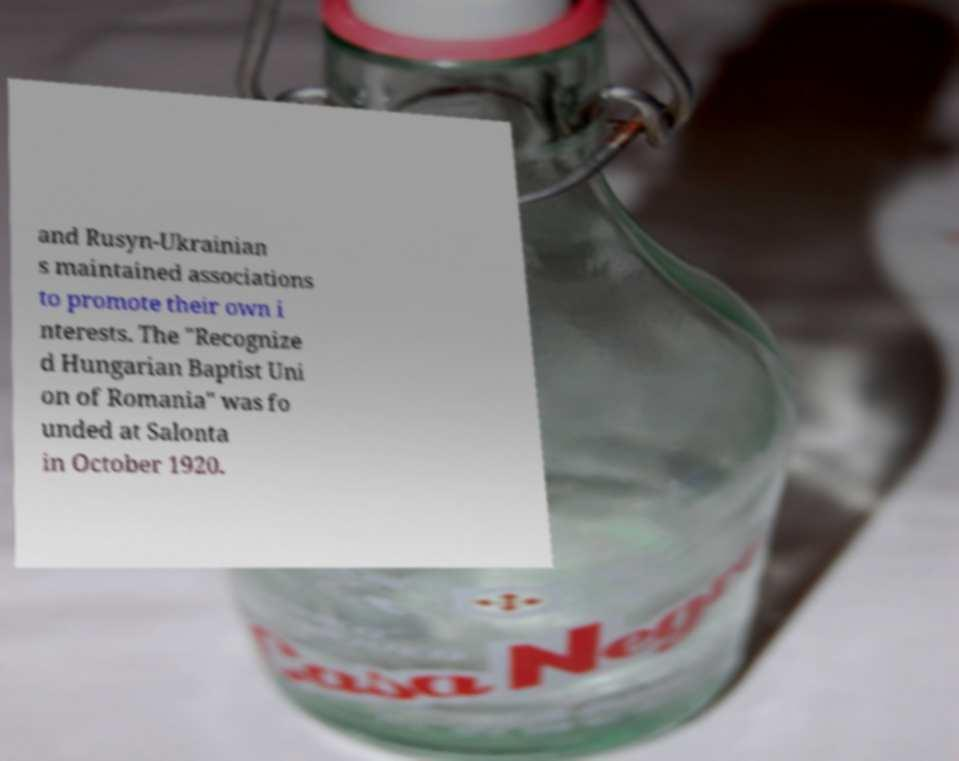Could you assist in decoding the text presented in this image and type it out clearly? and Rusyn-Ukrainian s maintained associations to promote their own i nterests. The "Recognize d Hungarian Baptist Uni on of Romania" was fo unded at Salonta in October 1920. 